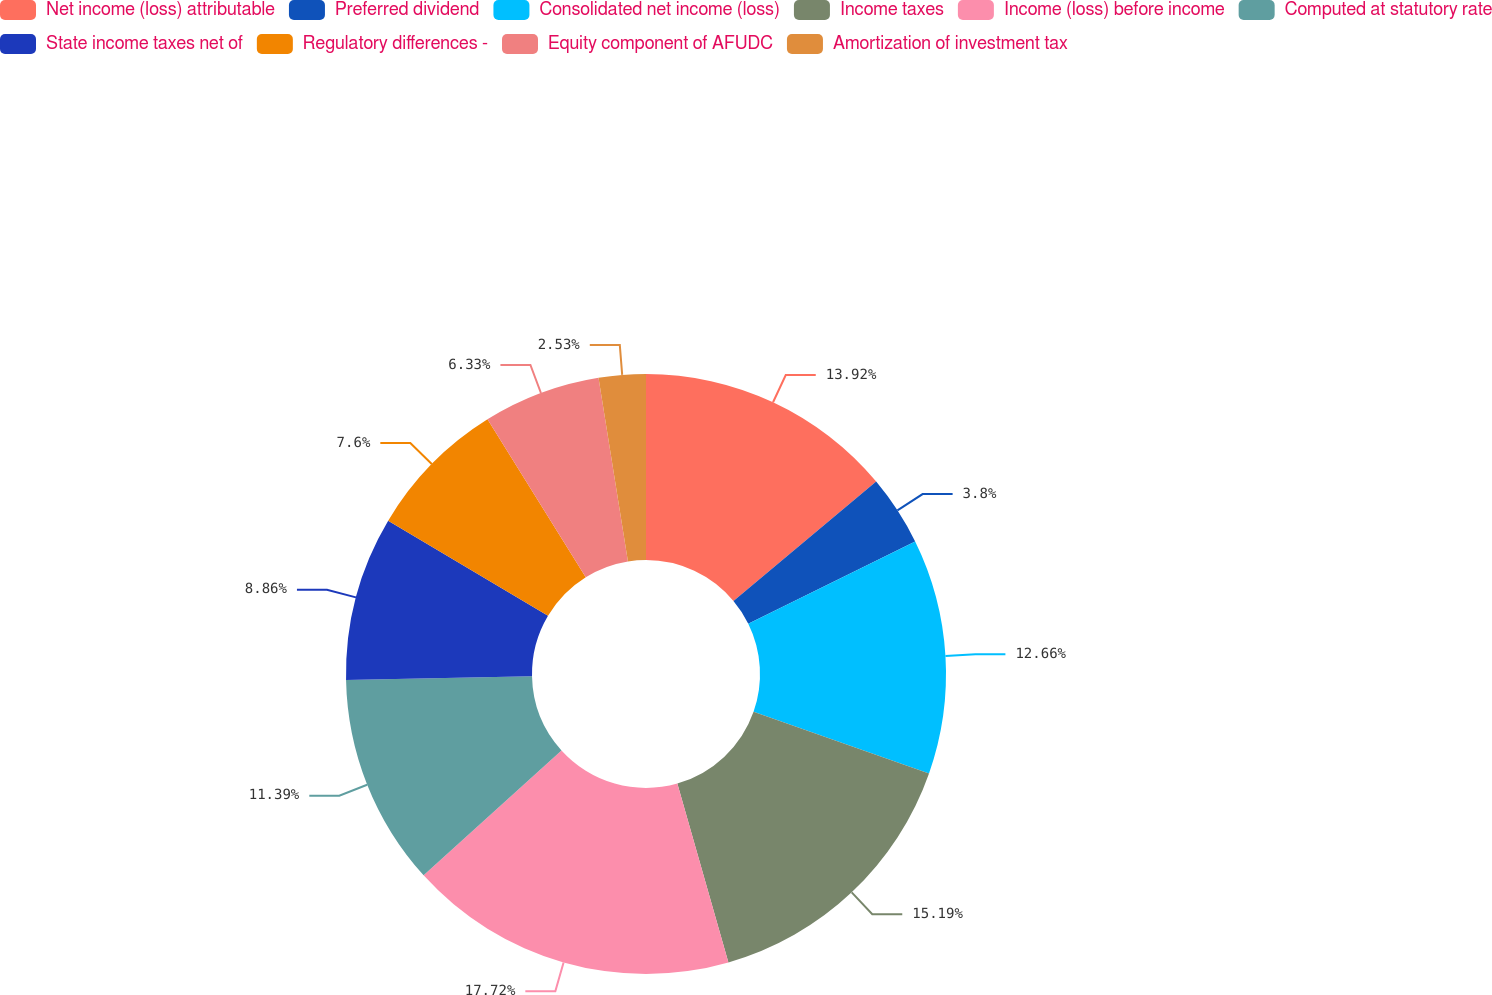Convert chart to OTSL. <chart><loc_0><loc_0><loc_500><loc_500><pie_chart><fcel>Net income (loss) attributable<fcel>Preferred dividend<fcel>Consolidated net income (loss)<fcel>Income taxes<fcel>Income (loss) before income<fcel>Computed at statutory rate<fcel>State income taxes net of<fcel>Regulatory differences -<fcel>Equity component of AFUDC<fcel>Amortization of investment tax<nl><fcel>13.92%<fcel>3.8%<fcel>12.66%<fcel>15.19%<fcel>17.72%<fcel>11.39%<fcel>8.86%<fcel>7.6%<fcel>6.33%<fcel>2.53%<nl></chart> 